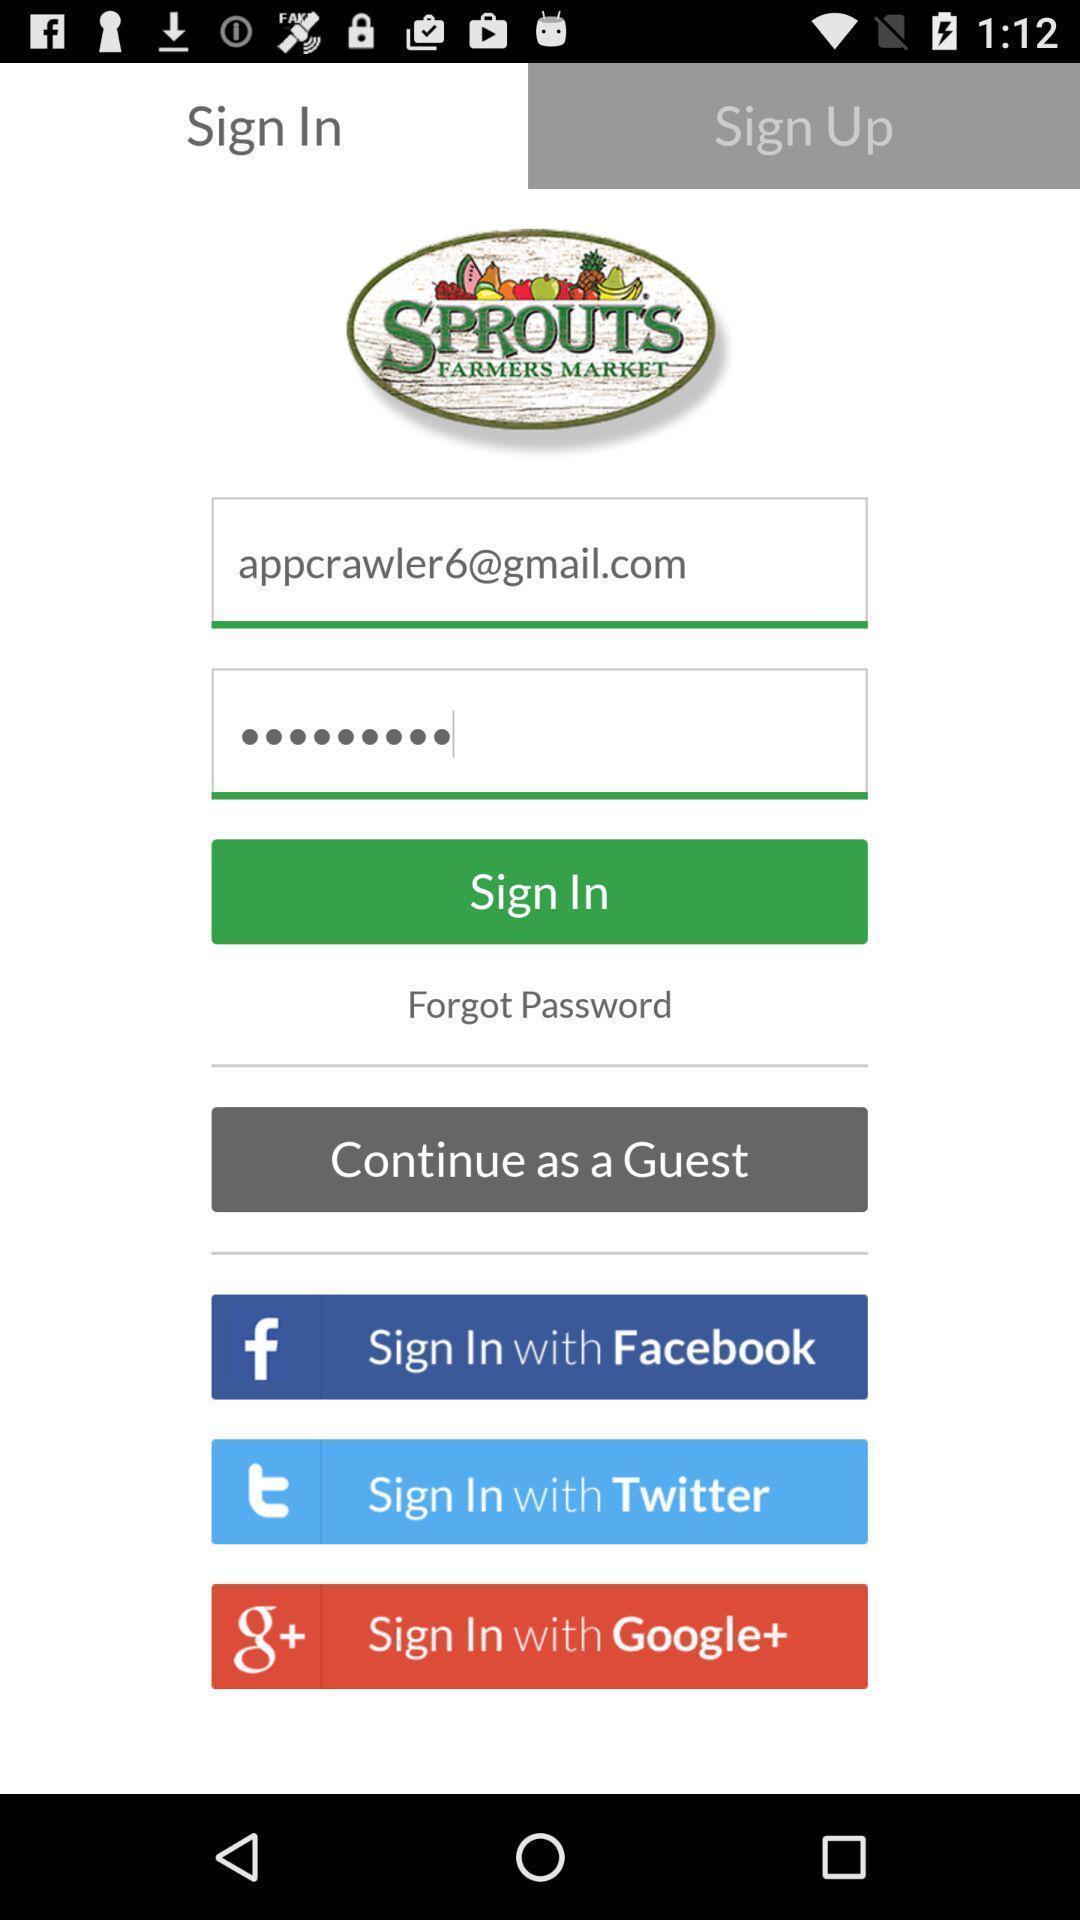Describe the visual elements of this screenshot. Sign in with different social applications displayed. 